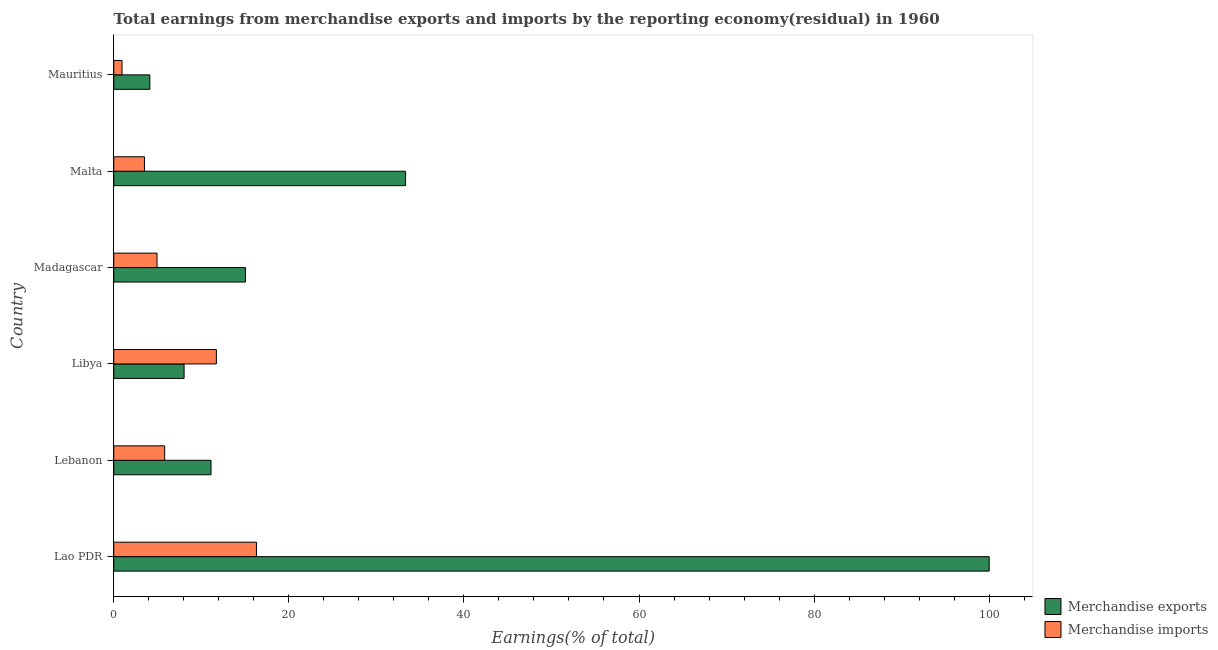How many bars are there on the 2nd tick from the bottom?
Your answer should be compact. 2. What is the label of the 6th group of bars from the top?
Give a very brief answer. Lao PDR. In how many cases, is the number of bars for a given country not equal to the number of legend labels?
Your answer should be very brief. 0. What is the earnings from merchandise imports in Lebanon?
Provide a succinct answer. 5.82. Across all countries, what is the minimum earnings from merchandise exports?
Offer a terse response. 4.12. In which country was the earnings from merchandise imports maximum?
Ensure brevity in your answer.  Lao PDR. In which country was the earnings from merchandise exports minimum?
Provide a succinct answer. Mauritius. What is the total earnings from merchandise exports in the graph?
Give a very brief answer. 171.65. What is the difference between the earnings from merchandise exports in Lao PDR and that in Madagascar?
Provide a succinct answer. 84.95. What is the difference between the earnings from merchandise exports in Libya and the earnings from merchandise imports in Madagascar?
Provide a succinct answer. 3.09. What is the average earnings from merchandise imports per country?
Your answer should be compact. 7.21. What is the difference between the earnings from merchandise imports and earnings from merchandise exports in Malta?
Provide a short and direct response. -29.82. In how many countries, is the earnings from merchandise imports greater than 60 %?
Offer a terse response. 0. What is the ratio of the earnings from merchandise exports in Madagascar to that in Mauritius?
Keep it short and to the point. 3.65. What is the difference between the highest and the second highest earnings from merchandise exports?
Your answer should be compact. 66.67. What is the difference between the highest and the lowest earnings from merchandise imports?
Your answer should be compact. 15.36. In how many countries, is the earnings from merchandise exports greater than the average earnings from merchandise exports taken over all countries?
Your answer should be very brief. 2. Is the sum of the earnings from merchandise exports in Lao PDR and Libya greater than the maximum earnings from merchandise imports across all countries?
Give a very brief answer. Yes. What does the 1st bar from the top in Libya represents?
Keep it short and to the point. Merchandise imports. What does the 2nd bar from the bottom in Libya represents?
Provide a short and direct response. Merchandise imports. What is the difference between two consecutive major ticks on the X-axis?
Ensure brevity in your answer.  20. Does the graph contain grids?
Make the answer very short. No. Where does the legend appear in the graph?
Provide a short and direct response. Bottom right. How many legend labels are there?
Your answer should be compact. 2. What is the title of the graph?
Keep it short and to the point. Total earnings from merchandise exports and imports by the reporting economy(residual) in 1960. Does "Age 65(female)" appear as one of the legend labels in the graph?
Ensure brevity in your answer.  No. What is the label or title of the X-axis?
Offer a terse response. Earnings(% of total). What is the label or title of the Y-axis?
Provide a succinct answer. Country. What is the Earnings(% of total) in Merchandise exports in Lao PDR?
Offer a very short reply. 100. What is the Earnings(% of total) in Merchandise imports in Lao PDR?
Your answer should be very brief. 16.3. What is the Earnings(% of total) in Merchandise exports in Lebanon?
Your answer should be compact. 11.11. What is the Earnings(% of total) in Merchandise imports in Lebanon?
Provide a succinct answer. 5.82. What is the Earnings(% of total) in Merchandise exports in Libya?
Provide a short and direct response. 8.04. What is the Earnings(% of total) of Merchandise imports in Libya?
Keep it short and to the point. 11.72. What is the Earnings(% of total) of Merchandise exports in Madagascar?
Ensure brevity in your answer.  15.05. What is the Earnings(% of total) in Merchandise imports in Madagascar?
Make the answer very short. 4.94. What is the Earnings(% of total) of Merchandise exports in Malta?
Offer a very short reply. 33.33. What is the Earnings(% of total) of Merchandise imports in Malta?
Your answer should be very brief. 3.51. What is the Earnings(% of total) of Merchandise exports in Mauritius?
Your response must be concise. 4.12. What is the Earnings(% of total) of Merchandise imports in Mauritius?
Your answer should be compact. 0.95. Across all countries, what is the maximum Earnings(% of total) in Merchandise imports?
Make the answer very short. 16.3. Across all countries, what is the minimum Earnings(% of total) in Merchandise exports?
Provide a short and direct response. 4.12. Across all countries, what is the minimum Earnings(% of total) of Merchandise imports?
Provide a short and direct response. 0.95. What is the total Earnings(% of total) of Merchandise exports in the graph?
Your answer should be compact. 171.65. What is the total Earnings(% of total) of Merchandise imports in the graph?
Make the answer very short. 43.24. What is the difference between the Earnings(% of total) of Merchandise exports in Lao PDR and that in Lebanon?
Your answer should be compact. 88.89. What is the difference between the Earnings(% of total) of Merchandise imports in Lao PDR and that in Lebanon?
Your answer should be very brief. 10.48. What is the difference between the Earnings(% of total) of Merchandise exports in Lao PDR and that in Libya?
Your answer should be compact. 91.96. What is the difference between the Earnings(% of total) in Merchandise imports in Lao PDR and that in Libya?
Offer a very short reply. 4.58. What is the difference between the Earnings(% of total) of Merchandise exports in Lao PDR and that in Madagascar?
Make the answer very short. 84.95. What is the difference between the Earnings(% of total) in Merchandise imports in Lao PDR and that in Madagascar?
Your answer should be very brief. 11.36. What is the difference between the Earnings(% of total) of Merchandise exports in Lao PDR and that in Malta?
Give a very brief answer. 66.67. What is the difference between the Earnings(% of total) in Merchandise imports in Lao PDR and that in Malta?
Provide a short and direct response. 12.79. What is the difference between the Earnings(% of total) of Merchandise exports in Lao PDR and that in Mauritius?
Keep it short and to the point. 95.88. What is the difference between the Earnings(% of total) in Merchandise imports in Lao PDR and that in Mauritius?
Ensure brevity in your answer.  15.36. What is the difference between the Earnings(% of total) in Merchandise exports in Lebanon and that in Libya?
Make the answer very short. 3.08. What is the difference between the Earnings(% of total) of Merchandise imports in Lebanon and that in Libya?
Your response must be concise. -5.9. What is the difference between the Earnings(% of total) of Merchandise exports in Lebanon and that in Madagascar?
Ensure brevity in your answer.  -3.94. What is the difference between the Earnings(% of total) in Merchandise imports in Lebanon and that in Madagascar?
Your answer should be very brief. 0.88. What is the difference between the Earnings(% of total) of Merchandise exports in Lebanon and that in Malta?
Give a very brief answer. -22.22. What is the difference between the Earnings(% of total) of Merchandise imports in Lebanon and that in Malta?
Keep it short and to the point. 2.31. What is the difference between the Earnings(% of total) of Merchandise exports in Lebanon and that in Mauritius?
Offer a terse response. 6.99. What is the difference between the Earnings(% of total) in Merchandise imports in Lebanon and that in Mauritius?
Give a very brief answer. 4.87. What is the difference between the Earnings(% of total) in Merchandise exports in Libya and that in Madagascar?
Your response must be concise. -7.01. What is the difference between the Earnings(% of total) of Merchandise imports in Libya and that in Madagascar?
Provide a short and direct response. 6.78. What is the difference between the Earnings(% of total) of Merchandise exports in Libya and that in Malta?
Offer a terse response. -25.3. What is the difference between the Earnings(% of total) of Merchandise imports in Libya and that in Malta?
Make the answer very short. 8.21. What is the difference between the Earnings(% of total) of Merchandise exports in Libya and that in Mauritius?
Your answer should be compact. 3.91. What is the difference between the Earnings(% of total) in Merchandise imports in Libya and that in Mauritius?
Offer a terse response. 10.78. What is the difference between the Earnings(% of total) of Merchandise exports in Madagascar and that in Malta?
Offer a very short reply. -18.28. What is the difference between the Earnings(% of total) of Merchandise imports in Madagascar and that in Malta?
Your answer should be compact. 1.43. What is the difference between the Earnings(% of total) in Merchandise exports in Madagascar and that in Mauritius?
Keep it short and to the point. 10.93. What is the difference between the Earnings(% of total) of Merchandise imports in Madagascar and that in Mauritius?
Provide a succinct answer. 4. What is the difference between the Earnings(% of total) in Merchandise exports in Malta and that in Mauritius?
Make the answer very short. 29.21. What is the difference between the Earnings(% of total) in Merchandise imports in Malta and that in Mauritius?
Offer a terse response. 2.56. What is the difference between the Earnings(% of total) in Merchandise exports in Lao PDR and the Earnings(% of total) in Merchandise imports in Lebanon?
Ensure brevity in your answer.  94.18. What is the difference between the Earnings(% of total) of Merchandise exports in Lao PDR and the Earnings(% of total) of Merchandise imports in Libya?
Your answer should be compact. 88.28. What is the difference between the Earnings(% of total) in Merchandise exports in Lao PDR and the Earnings(% of total) in Merchandise imports in Madagascar?
Your answer should be very brief. 95.06. What is the difference between the Earnings(% of total) in Merchandise exports in Lao PDR and the Earnings(% of total) in Merchandise imports in Malta?
Your answer should be very brief. 96.49. What is the difference between the Earnings(% of total) in Merchandise exports in Lao PDR and the Earnings(% of total) in Merchandise imports in Mauritius?
Your answer should be compact. 99.05. What is the difference between the Earnings(% of total) of Merchandise exports in Lebanon and the Earnings(% of total) of Merchandise imports in Libya?
Your response must be concise. -0.61. What is the difference between the Earnings(% of total) of Merchandise exports in Lebanon and the Earnings(% of total) of Merchandise imports in Madagascar?
Ensure brevity in your answer.  6.17. What is the difference between the Earnings(% of total) in Merchandise exports in Lebanon and the Earnings(% of total) in Merchandise imports in Malta?
Your answer should be compact. 7.6. What is the difference between the Earnings(% of total) in Merchandise exports in Lebanon and the Earnings(% of total) in Merchandise imports in Mauritius?
Make the answer very short. 10.16. What is the difference between the Earnings(% of total) in Merchandise exports in Libya and the Earnings(% of total) in Merchandise imports in Madagascar?
Provide a succinct answer. 3.09. What is the difference between the Earnings(% of total) in Merchandise exports in Libya and the Earnings(% of total) in Merchandise imports in Malta?
Your response must be concise. 4.53. What is the difference between the Earnings(% of total) of Merchandise exports in Libya and the Earnings(% of total) of Merchandise imports in Mauritius?
Ensure brevity in your answer.  7.09. What is the difference between the Earnings(% of total) in Merchandise exports in Madagascar and the Earnings(% of total) in Merchandise imports in Malta?
Make the answer very short. 11.54. What is the difference between the Earnings(% of total) of Merchandise exports in Madagascar and the Earnings(% of total) of Merchandise imports in Mauritius?
Offer a terse response. 14.1. What is the difference between the Earnings(% of total) in Merchandise exports in Malta and the Earnings(% of total) in Merchandise imports in Mauritius?
Offer a very short reply. 32.39. What is the average Earnings(% of total) of Merchandise exports per country?
Give a very brief answer. 28.61. What is the average Earnings(% of total) in Merchandise imports per country?
Make the answer very short. 7.21. What is the difference between the Earnings(% of total) of Merchandise exports and Earnings(% of total) of Merchandise imports in Lao PDR?
Give a very brief answer. 83.7. What is the difference between the Earnings(% of total) of Merchandise exports and Earnings(% of total) of Merchandise imports in Lebanon?
Your answer should be compact. 5.29. What is the difference between the Earnings(% of total) in Merchandise exports and Earnings(% of total) in Merchandise imports in Libya?
Your response must be concise. -3.69. What is the difference between the Earnings(% of total) in Merchandise exports and Earnings(% of total) in Merchandise imports in Madagascar?
Provide a succinct answer. 10.11. What is the difference between the Earnings(% of total) of Merchandise exports and Earnings(% of total) of Merchandise imports in Malta?
Your response must be concise. 29.82. What is the difference between the Earnings(% of total) in Merchandise exports and Earnings(% of total) in Merchandise imports in Mauritius?
Provide a short and direct response. 3.18. What is the ratio of the Earnings(% of total) of Merchandise imports in Lao PDR to that in Lebanon?
Make the answer very short. 2.8. What is the ratio of the Earnings(% of total) in Merchandise exports in Lao PDR to that in Libya?
Offer a terse response. 12.44. What is the ratio of the Earnings(% of total) in Merchandise imports in Lao PDR to that in Libya?
Provide a short and direct response. 1.39. What is the ratio of the Earnings(% of total) in Merchandise exports in Lao PDR to that in Madagascar?
Your answer should be very brief. 6.64. What is the ratio of the Earnings(% of total) of Merchandise imports in Lao PDR to that in Madagascar?
Your response must be concise. 3.3. What is the ratio of the Earnings(% of total) of Merchandise imports in Lao PDR to that in Malta?
Your answer should be compact. 4.65. What is the ratio of the Earnings(% of total) in Merchandise exports in Lao PDR to that in Mauritius?
Give a very brief answer. 24.25. What is the ratio of the Earnings(% of total) in Merchandise imports in Lao PDR to that in Mauritius?
Ensure brevity in your answer.  17.22. What is the ratio of the Earnings(% of total) in Merchandise exports in Lebanon to that in Libya?
Offer a very short reply. 1.38. What is the ratio of the Earnings(% of total) of Merchandise imports in Lebanon to that in Libya?
Ensure brevity in your answer.  0.5. What is the ratio of the Earnings(% of total) in Merchandise exports in Lebanon to that in Madagascar?
Offer a very short reply. 0.74. What is the ratio of the Earnings(% of total) in Merchandise imports in Lebanon to that in Madagascar?
Give a very brief answer. 1.18. What is the ratio of the Earnings(% of total) in Merchandise exports in Lebanon to that in Malta?
Make the answer very short. 0.33. What is the ratio of the Earnings(% of total) in Merchandise imports in Lebanon to that in Malta?
Offer a terse response. 1.66. What is the ratio of the Earnings(% of total) of Merchandise exports in Lebanon to that in Mauritius?
Your response must be concise. 2.69. What is the ratio of the Earnings(% of total) of Merchandise imports in Lebanon to that in Mauritius?
Your answer should be very brief. 6.15. What is the ratio of the Earnings(% of total) in Merchandise exports in Libya to that in Madagascar?
Your answer should be compact. 0.53. What is the ratio of the Earnings(% of total) in Merchandise imports in Libya to that in Madagascar?
Your response must be concise. 2.37. What is the ratio of the Earnings(% of total) in Merchandise exports in Libya to that in Malta?
Your response must be concise. 0.24. What is the ratio of the Earnings(% of total) of Merchandise imports in Libya to that in Malta?
Your response must be concise. 3.34. What is the ratio of the Earnings(% of total) in Merchandise exports in Libya to that in Mauritius?
Offer a terse response. 1.95. What is the ratio of the Earnings(% of total) of Merchandise imports in Libya to that in Mauritius?
Your response must be concise. 12.38. What is the ratio of the Earnings(% of total) of Merchandise exports in Madagascar to that in Malta?
Your answer should be compact. 0.45. What is the ratio of the Earnings(% of total) of Merchandise imports in Madagascar to that in Malta?
Your answer should be compact. 1.41. What is the ratio of the Earnings(% of total) of Merchandise exports in Madagascar to that in Mauritius?
Your answer should be compact. 3.65. What is the ratio of the Earnings(% of total) of Merchandise imports in Madagascar to that in Mauritius?
Ensure brevity in your answer.  5.22. What is the ratio of the Earnings(% of total) in Merchandise exports in Malta to that in Mauritius?
Offer a terse response. 8.08. What is the ratio of the Earnings(% of total) of Merchandise imports in Malta to that in Mauritius?
Make the answer very short. 3.71. What is the difference between the highest and the second highest Earnings(% of total) of Merchandise exports?
Offer a very short reply. 66.67. What is the difference between the highest and the second highest Earnings(% of total) of Merchandise imports?
Your answer should be compact. 4.58. What is the difference between the highest and the lowest Earnings(% of total) in Merchandise exports?
Keep it short and to the point. 95.88. What is the difference between the highest and the lowest Earnings(% of total) in Merchandise imports?
Provide a succinct answer. 15.36. 